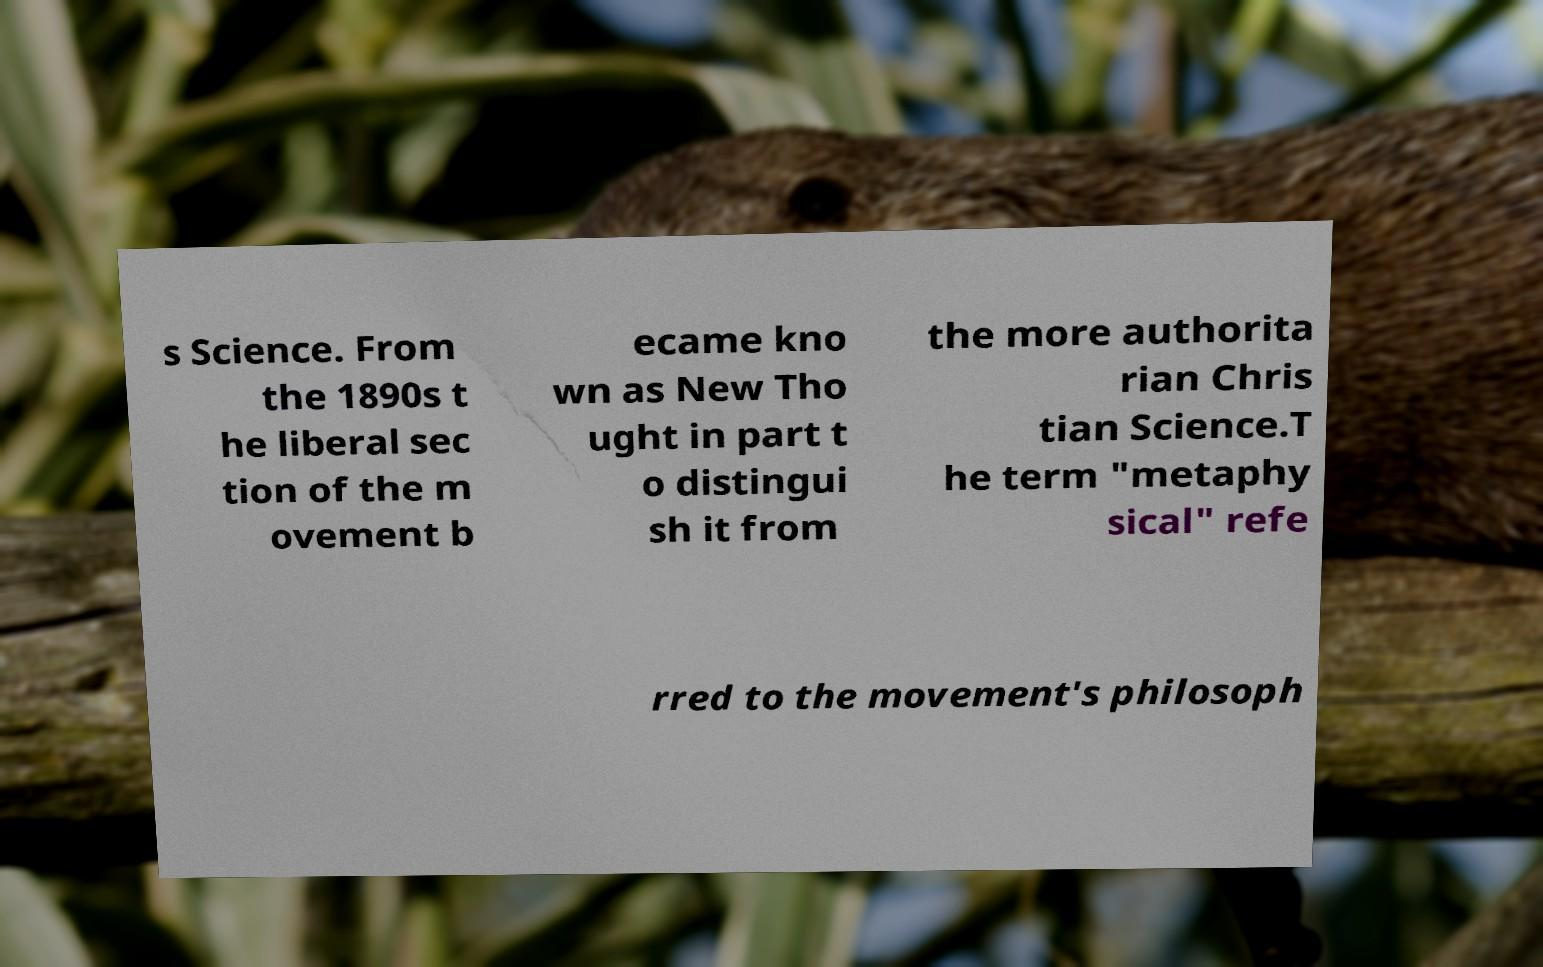Can you accurately transcribe the text from the provided image for me? s Science. From the 1890s t he liberal sec tion of the m ovement b ecame kno wn as New Tho ught in part t o distingui sh it from the more authorita rian Chris tian Science.T he term "metaphy sical" refe rred to the movement's philosoph 